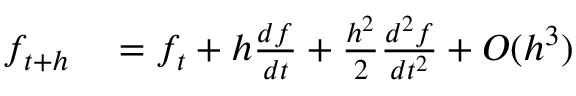Convert formula to latex. <formula><loc_0><loc_0><loc_500><loc_500>\begin{array} { r l } { f _ { t + h } } & = f _ { t } + h \frac { d f } { d t } + \frac { h ^ { 2 } } { 2 } \frac { d ^ { 2 } f } { d t ^ { 2 } } + O ( h ^ { 3 } ) } \end{array}</formula> 